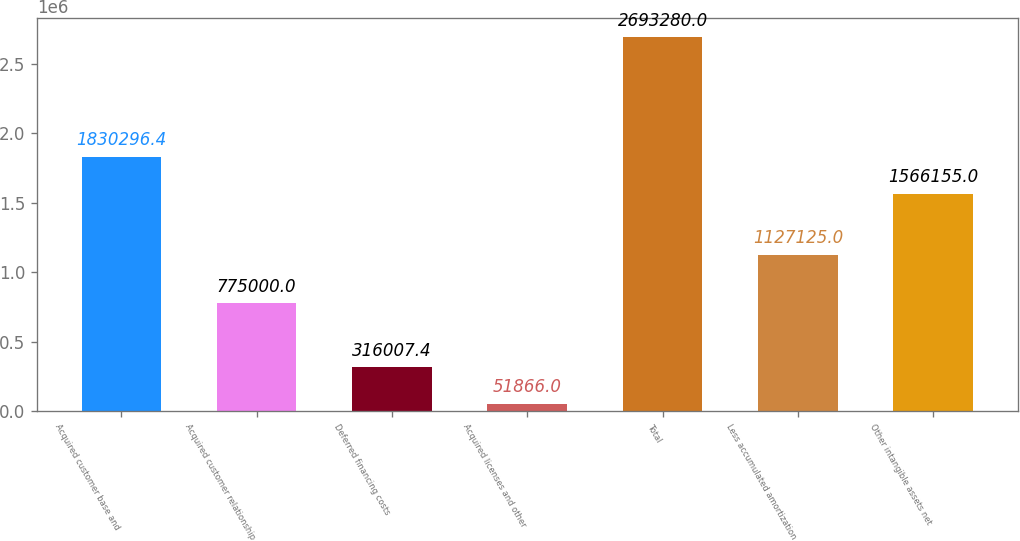<chart> <loc_0><loc_0><loc_500><loc_500><bar_chart><fcel>Acquired customer base and<fcel>Acquired customer relationship<fcel>Deferred financing costs<fcel>Acquired licenses and other<fcel>Total<fcel>Less accumulated amortization<fcel>Other intangible assets net<nl><fcel>1.8303e+06<fcel>775000<fcel>316007<fcel>51866<fcel>2.69328e+06<fcel>1.12712e+06<fcel>1.56616e+06<nl></chart> 